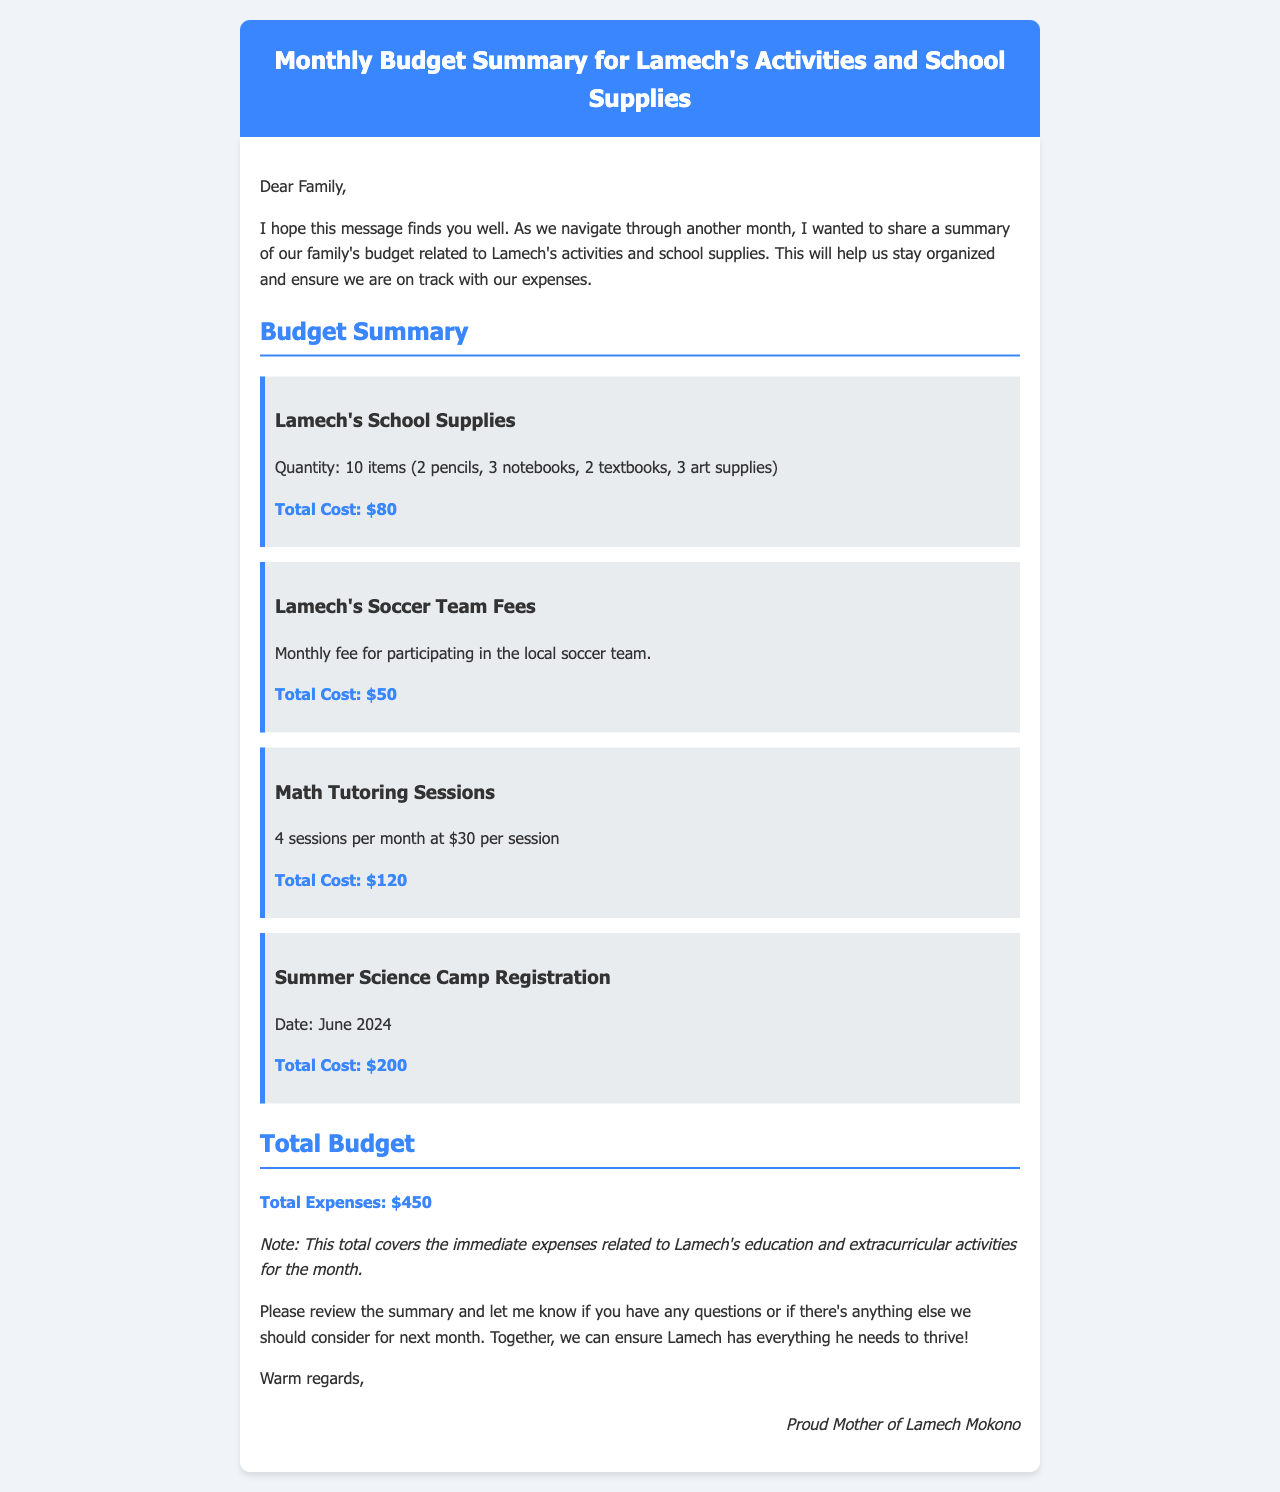What is the total cost for Lamech's school supplies? The total cost for Lamech's school supplies is listed in the budget summary section as $80.
Answer: $80 How many art supplies did Lamech need? The document specifies that Lamech needed 3 art supplies as part of his school supplies.
Answer: 3 art supplies What is the monthly fee for Lamech's soccer team? The document states that the total cost for participating in the local soccer team is $50.
Answer: $50 How many math tutoring sessions are there per month? It is mentioned in the document that there are 4 math tutoring sessions per month.
Answer: 4 sessions What is the total expense outlined in the document? The total expenses for the month, summing all activities and supplies, is mentioned as $450.
Answer: $450 What date is mentioned for the summer science camp registration? The document refers to the summer science camp registration date as June 2024.
Answer: June 2024 What is the cost per session for math tutoring? The document provides the cost per math tutoring session as $30.
Answer: $30 How many textbooks did Lamech receive? The document specifies that Lamech received 2 textbooks as part of his school supplies.
Answer: 2 textbooks Who is the sender of the budget summary? The document identifies the sender as "Proud Mother of Lamech Mokono."
Answer: Proud Mother of Lamech Mokono 